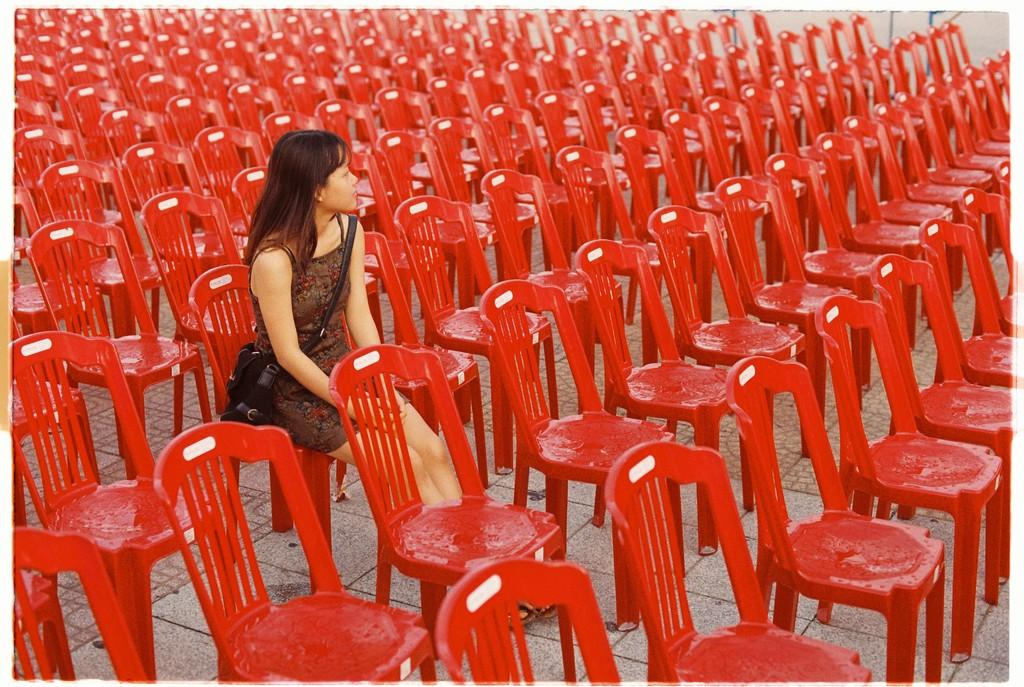Who is the main subject in the image? There is a woman in the image. What is the woman holding in the image? The woman is holding a bag across her shoulders. What is the woman's position in the image? The woman is sitting in a chair. How many chairs are visible in the image? There are many red chairs in the image. How are the chairs arranged in the image? The chairs are arranged in an orderly manner. What is the design of the chair the woman is sitting on? The provided facts do not mention the design of the chair, so we cannot determine the design from the image. 